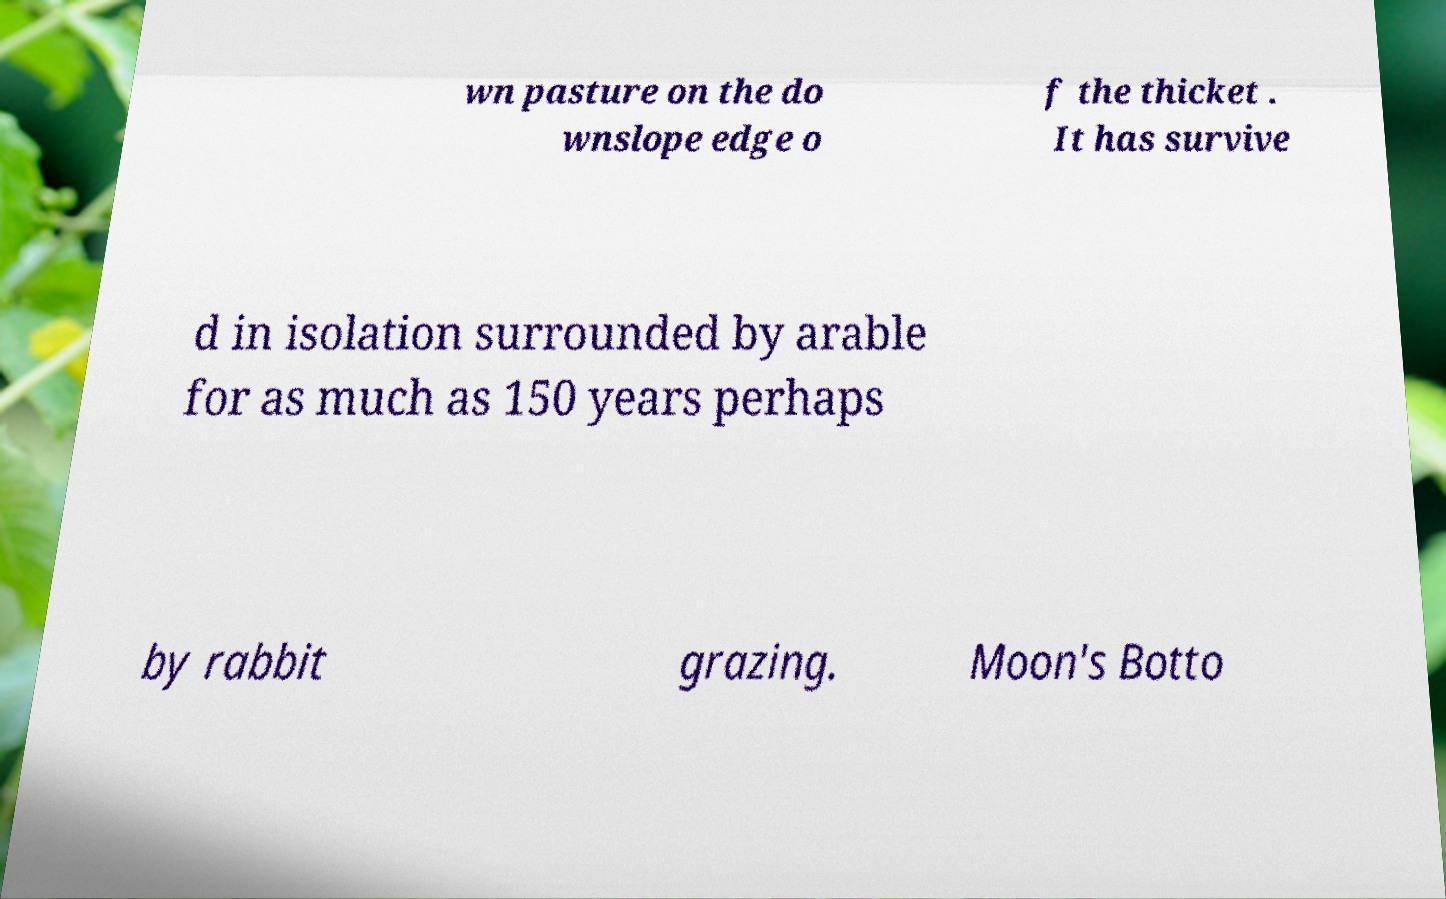I need the written content from this picture converted into text. Can you do that? wn pasture on the do wnslope edge o f the thicket . It has survive d in isolation surrounded by arable for as much as 150 years perhaps by rabbit grazing. Moon's Botto 